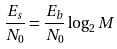Convert formula to latex. <formula><loc_0><loc_0><loc_500><loc_500>\frac { E _ { s } } { N _ { 0 } } = \frac { E _ { b } } { N _ { 0 } } \log _ { 2 } M</formula> 